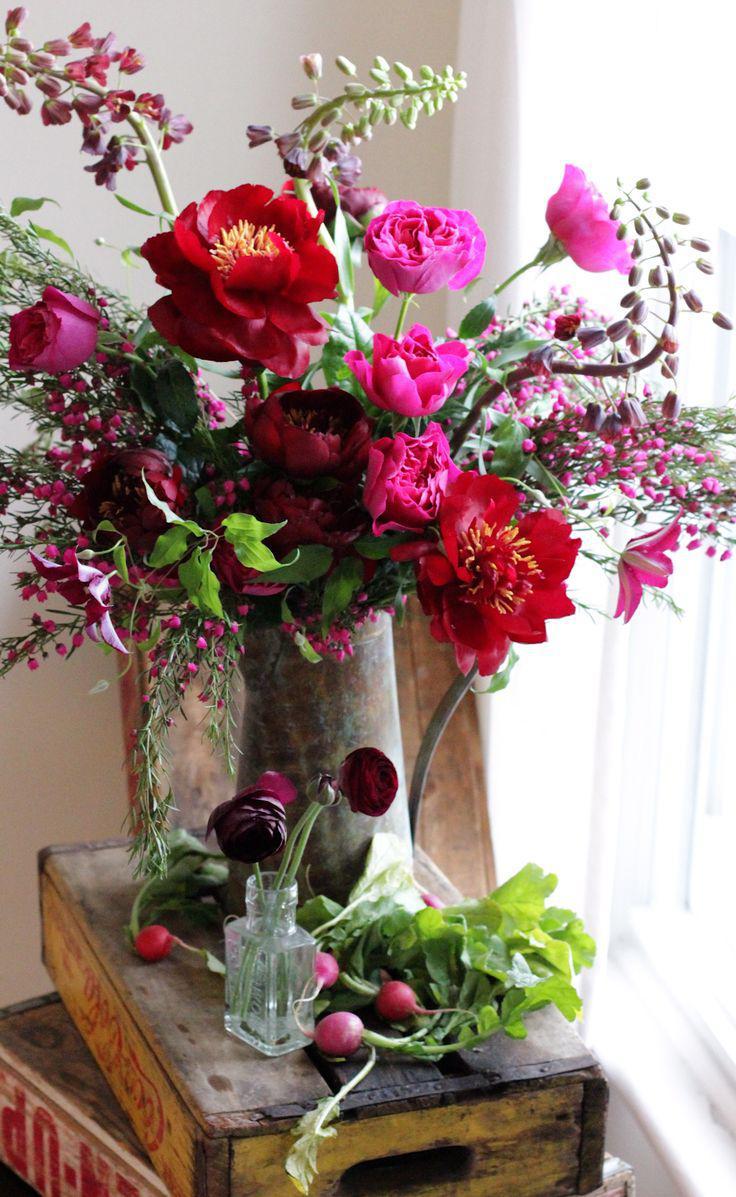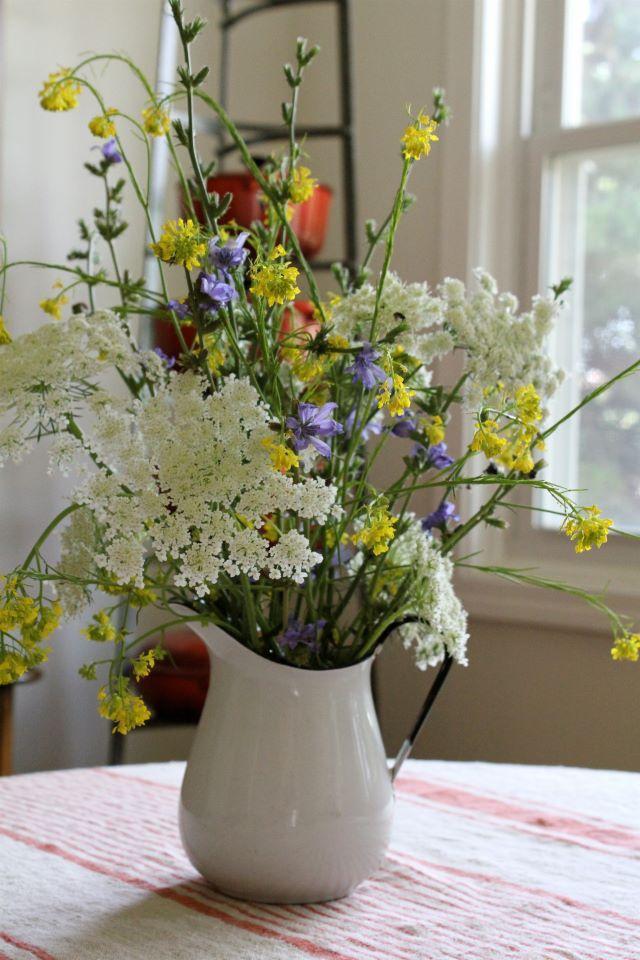The first image is the image on the left, the second image is the image on the right. Evaluate the accuracy of this statement regarding the images: "One image features a single floral arrangement, which includes long stems with yellow flowers in an opaque container with at least one handle.". Is it true? Answer yes or no. Yes. The first image is the image on the left, the second image is the image on the right. Assess this claim about the two images: "In one of the images there is at least one bouquet in a clear glass vase.". Correct or not? Answer yes or no. No. 